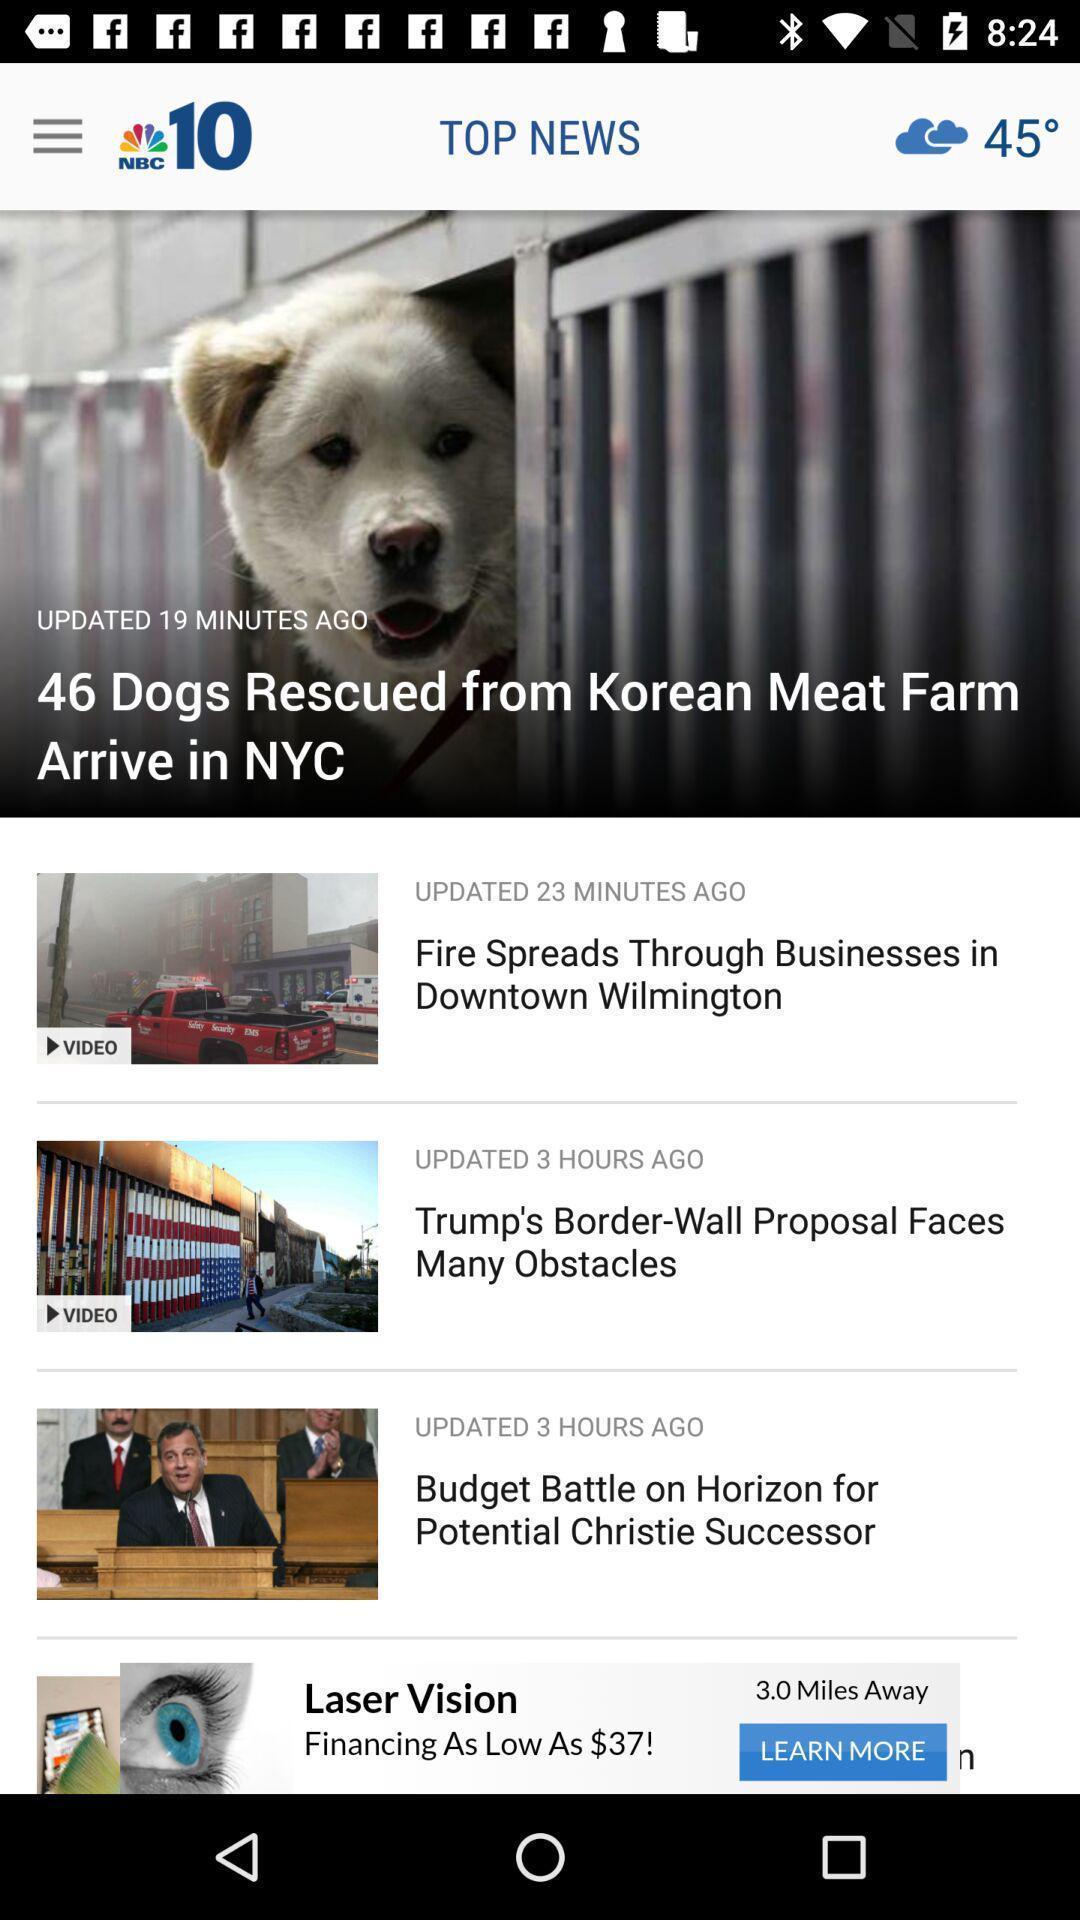What details can you identify in this image? Screen page displaying various articles in news application. 